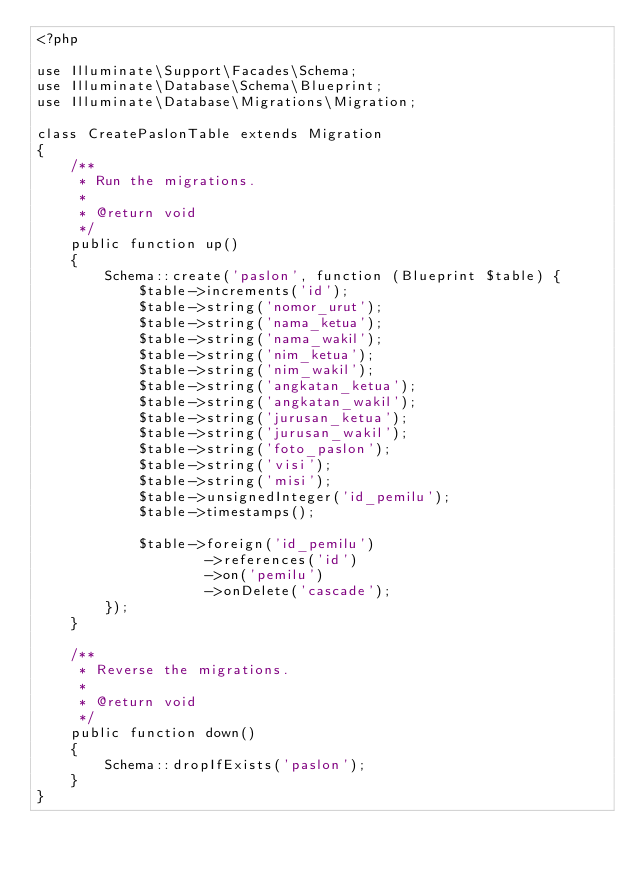<code> <loc_0><loc_0><loc_500><loc_500><_PHP_><?php

use Illuminate\Support\Facades\Schema;
use Illuminate\Database\Schema\Blueprint;
use Illuminate\Database\Migrations\Migration;

class CreatePaslonTable extends Migration
{
    /**
     * Run the migrations.
     *
     * @return void
     */
    public function up()
    {
        Schema::create('paslon', function (Blueprint $table) {
            $table->increments('id');
            $table->string('nomor_urut');
            $table->string('nama_ketua');
            $table->string('nama_wakil');
            $table->string('nim_ketua');
            $table->string('nim_wakil');
            $table->string('angkatan_ketua');
            $table->string('angkatan_wakil');
            $table->string('jurusan_ketua');
            $table->string('jurusan_wakil');
            $table->string('foto_paslon');
            $table->string('visi');
            $table->string('misi');
            $table->unsignedInteger('id_pemilu');
            $table->timestamps();

            $table->foreign('id_pemilu')
                    ->references('id')
                    ->on('pemilu')
                    ->onDelete('cascade');
        });
    }

    /**
     * Reverse the migrations.
     *
     * @return void
     */
    public function down()
    {
        Schema::dropIfExists('paslon');
    }
}
</code> 